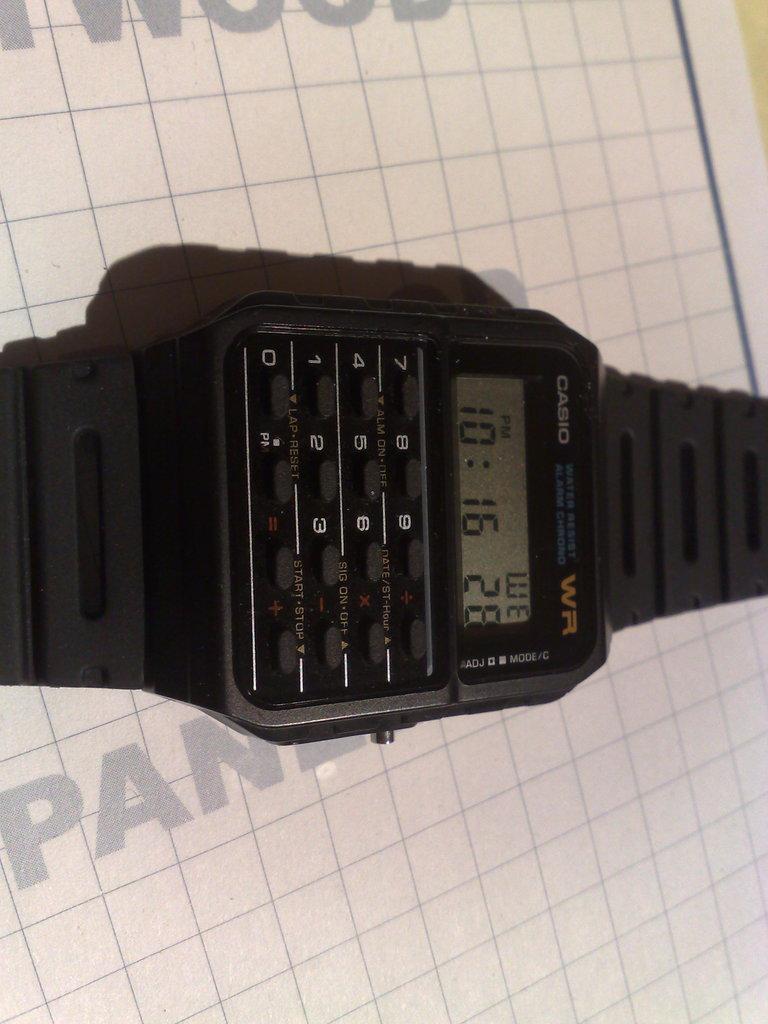What is the time shown on this watch?
Offer a very short reply. 10:16. Who is the manufacturer of the watch?
Give a very brief answer. Casio. 